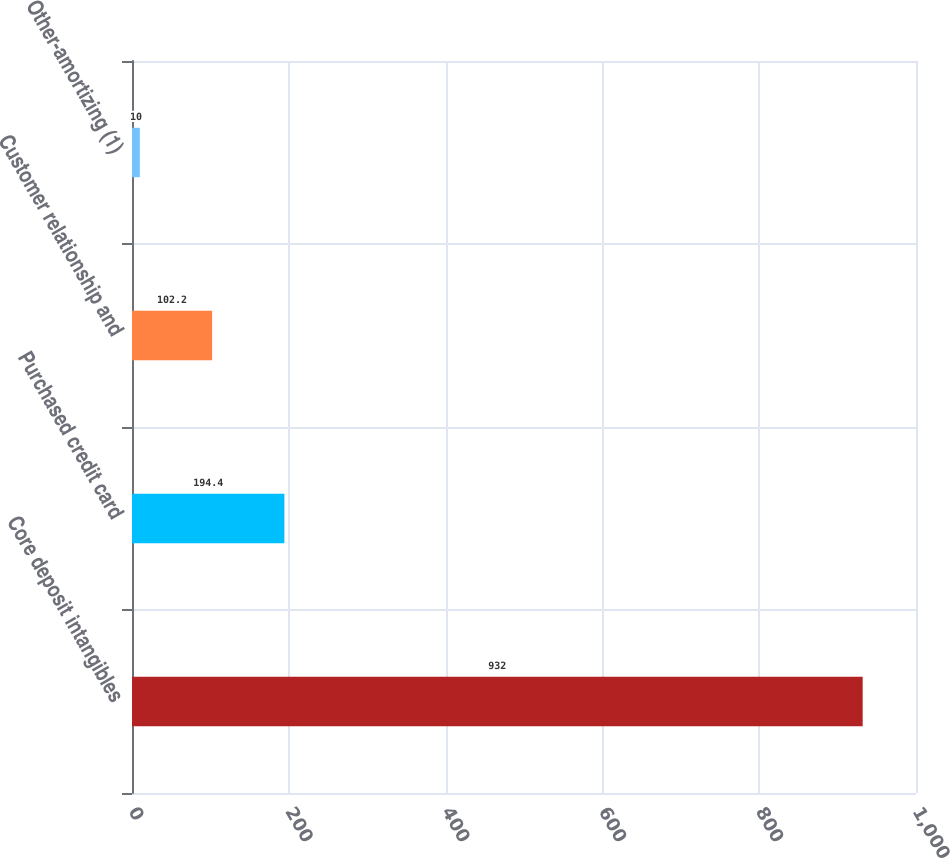Convert chart to OTSL. <chart><loc_0><loc_0><loc_500><loc_500><bar_chart><fcel>Core deposit intangibles<fcel>Purchased credit card<fcel>Customer relationship and<fcel>Other-amortizing (1)<nl><fcel>932<fcel>194.4<fcel>102.2<fcel>10<nl></chart> 